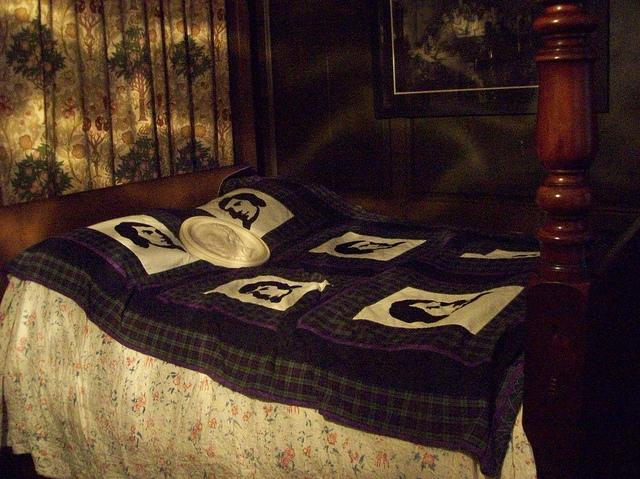What is on the bed? blanket 